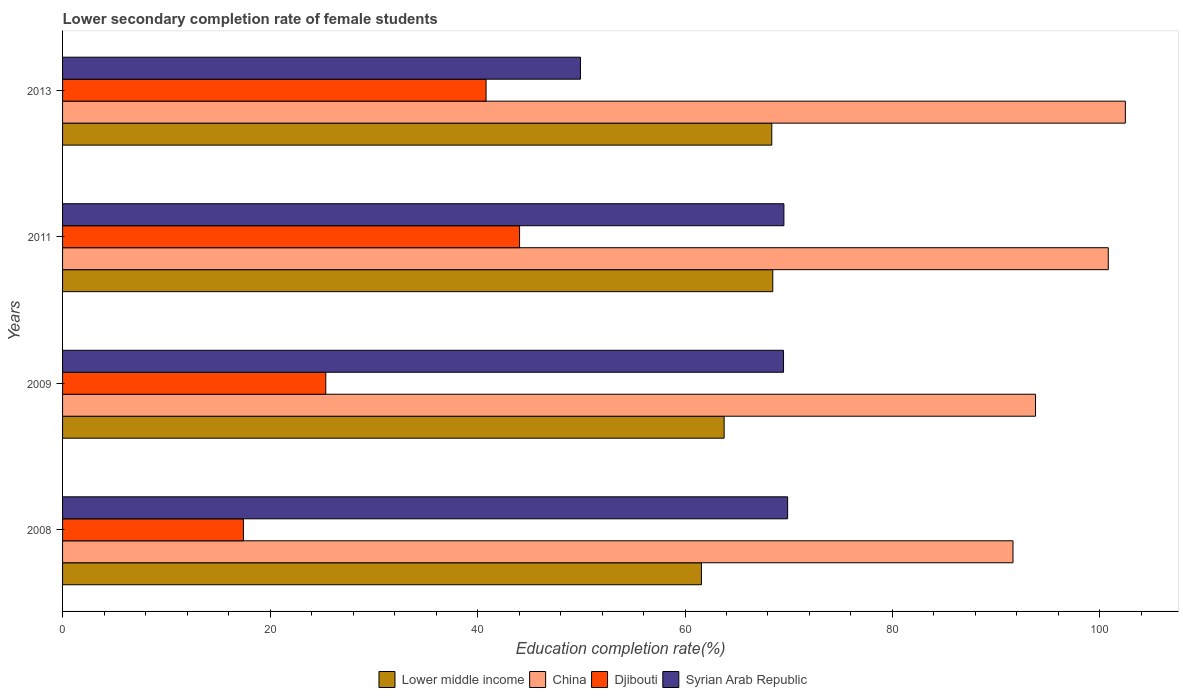Are the number of bars per tick equal to the number of legend labels?
Provide a short and direct response. Yes. How many bars are there on the 3rd tick from the top?
Keep it short and to the point. 4. How many bars are there on the 2nd tick from the bottom?
Your answer should be very brief. 4. In how many cases, is the number of bars for a given year not equal to the number of legend labels?
Offer a terse response. 0. What is the lower secondary completion rate of female students in China in 2011?
Offer a terse response. 100.8. Across all years, what is the maximum lower secondary completion rate of female students in China?
Offer a terse response. 102.45. Across all years, what is the minimum lower secondary completion rate of female students in Djibouti?
Offer a terse response. 17.43. What is the total lower secondary completion rate of female students in China in the graph?
Offer a very short reply. 388.66. What is the difference between the lower secondary completion rate of female students in China in 2008 and that in 2009?
Give a very brief answer. -2.17. What is the difference between the lower secondary completion rate of female students in Syrian Arab Republic in 2011 and the lower secondary completion rate of female students in China in 2008?
Your answer should be very brief. -22.08. What is the average lower secondary completion rate of female students in China per year?
Your response must be concise. 97.17. In the year 2008, what is the difference between the lower secondary completion rate of female students in China and lower secondary completion rate of female students in Djibouti?
Your answer should be compact. 74.18. What is the ratio of the lower secondary completion rate of female students in China in 2008 to that in 2013?
Your answer should be compact. 0.89. Is the lower secondary completion rate of female students in Syrian Arab Republic in 2009 less than that in 2011?
Your answer should be very brief. Yes. Is the difference between the lower secondary completion rate of female students in China in 2011 and 2013 greater than the difference between the lower secondary completion rate of female students in Djibouti in 2011 and 2013?
Offer a terse response. No. What is the difference between the highest and the second highest lower secondary completion rate of female students in Syrian Arab Republic?
Your answer should be very brief. 0.36. What is the difference between the highest and the lowest lower secondary completion rate of female students in Lower middle income?
Offer a very short reply. 6.88. Is the sum of the lower secondary completion rate of female students in Syrian Arab Republic in 2011 and 2013 greater than the maximum lower secondary completion rate of female students in Lower middle income across all years?
Give a very brief answer. Yes. Is it the case that in every year, the sum of the lower secondary completion rate of female students in Lower middle income and lower secondary completion rate of female students in China is greater than the sum of lower secondary completion rate of female students in Syrian Arab Republic and lower secondary completion rate of female students in Djibouti?
Provide a succinct answer. Yes. What does the 4th bar from the top in 2009 represents?
Provide a short and direct response. Lower middle income. What does the 1st bar from the bottom in 2008 represents?
Your response must be concise. Lower middle income. Are all the bars in the graph horizontal?
Offer a very short reply. Yes. Does the graph contain grids?
Your answer should be compact. No. How are the legend labels stacked?
Your response must be concise. Horizontal. What is the title of the graph?
Make the answer very short. Lower secondary completion rate of female students. What is the label or title of the X-axis?
Provide a short and direct response. Education completion rate(%). What is the label or title of the Y-axis?
Make the answer very short. Years. What is the Education completion rate(%) of Lower middle income in 2008?
Give a very brief answer. 61.59. What is the Education completion rate(%) in China in 2008?
Your response must be concise. 91.62. What is the Education completion rate(%) in Djibouti in 2008?
Offer a terse response. 17.43. What is the Education completion rate(%) of Syrian Arab Republic in 2008?
Provide a short and direct response. 69.9. What is the Education completion rate(%) of Lower middle income in 2009?
Offer a terse response. 63.77. What is the Education completion rate(%) of China in 2009?
Keep it short and to the point. 93.79. What is the Education completion rate(%) of Djibouti in 2009?
Ensure brevity in your answer.  25.38. What is the Education completion rate(%) in Syrian Arab Republic in 2009?
Provide a succinct answer. 69.5. What is the Education completion rate(%) in Lower middle income in 2011?
Your answer should be very brief. 68.46. What is the Education completion rate(%) in China in 2011?
Provide a succinct answer. 100.8. What is the Education completion rate(%) in Djibouti in 2011?
Your answer should be very brief. 44.05. What is the Education completion rate(%) of Syrian Arab Republic in 2011?
Make the answer very short. 69.54. What is the Education completion rate(%) in Lower middle income in 2013?
Offer a very short reply. 68.37. What is the Education completion rate(%) of China in 2013?
Provide a short and direct response. 102.45. What is the Education completion rate(%) in Djibouti in 2013?
Provide a short and direct response. 40.82. What is the Education completion rate(%) of Syrian Arab Republic in 2013?
Keep it short and to the point. 49.92. Across all years, what is the maximum Education completion rate(%) in Lower middle income?
Your response must be concise. 68.46. Across all years, what is the maximum Education completion rate(%) in China?
Provide a succinct answer. 102.45. Across all years, what is the maximum Education completion rate(%) of Djibouti?
Make the answer very short. 44.05. Across all years, what is the maximum Education completion rate(%) in Syrian Arab Republic?
Provide a short and direct response. 69.9. Across all years, what is the minimum Education completion rate(%) in Lower middle income?
Your answer should be compact. 61.59. Across all years, what is the minimum Education completion rate(%) of China?
Give a very brief answer. 91.62. Across all years, what is the minimum Education completion rate(%) of Djibouti?
Ensure brevity in your answer.  17.43. Across all years, what is the minimum Education completion rate(%) of Syrian Arab Republic?
Offer a very short reply. 49.92. What is the total Education completion rate(%) of Lower middle income in the graph?
Offer a terse response. 262.19. What is the total Education completion rate(%) of China in the graph?
Your response must be concise. 388.66. What is the total Education completion rate(%) in Djibouti in the graph?
Provide a succinct answer. 127.69. What is the total Education completion rate(%) in Syrian Arab Republic in the graph?
Make the answer very short. 258.85. What is the difference between the Education completion rate(%) of Lower middle income in 2008 and that in 2009?
Your answer should be very brief. -2.19. What is the difference between the Education completion rate(%) in China in 2008 and that in 2009?
Make the answer very short. -2.17. What is the difference between the Education completion rate(%) in Djibouti in 2008 and that in 2009?
Keep it short and to the point. -7.94. What is the difference between the Education completion rate(%) of Syrian Arab Republic in 2008 and that in 2009?
Offer a very short reply. 0.4. What is the difference between the Education completion rate(%) in Lower middle income in 2008 and that in 2011?
Keep it short and to the point. -6.88. What is the difference between the Education completion rate(%) in China in 2008 and that in 2011?
Keep it short and to the point. -9.18. What is the difference between the Education completion rate(%) in Djibouti in 2008 and that in 2011?
Provide a short and direct response. -26.62. What is the difference between the Education completion rate(%) of Syrian Arab Republic in 2008 and that in 2011?
Ensure brevity in your answer.  0.36. What is the difference between the Education completion rate(%) in Lower middle income in 2008 and that in 2013?
Provide a succinct answer. -6.78. What is the difference between the Education completion rate(%) of China in 2008 and that in 2013?
Your response must be concise. -10.83. What is the difference between the Education completion rate(%) of Djibouti in 2008 and that in 2013?
Your response must be concise. -23.39. What is the difference between the Education completion rate(%) of Syrian Arab Republic in 2008 and that in 2013?
Offer a terse response. 19.97. What is the difference between the Education completion rate(%) in Lower middle income in 2009 and that in 2011?
Provide a short and direct response. -4.69. What is the difference between the Education completion rate(%) in China in 2009 and that in 2011?
Offer a terse response. -7.01. What is the difference between the Education completion rate(%) in Djibouti in 2009 and that in 2011?
Offer a very short reply. -18.68. What is the difference between the Education completion rate(%) in Syrian Arab Republic in 2009 and that in 2011?
Provide a short and direct response. -0.04. What is the difference between the Education completion rate(%) in Lower middle income in 2009 and that in 2013?
Offer a terse response. -4.59. What is the difference between the Education completion rate(%) in China in 2009 and that in 2013?
Offer a terse response. -8.66. What is the difference between the Education completion rate(%) of Djibouti in 2009 and that in 2013?
Make the answer very short. -15.45. What is the difference between the Education completion rate(%) in Syrian Arab Republic in 2009 and that in 2013?
Ensure brevity in your answer.  19.58. What is the difference between the Education completion rate(%) in Lower middle income in 2011 and that in 2013?
Make the answer very short. 0.09. What is the difference between the Education completion rate(%) in China in 2011 and that in 2013?
Give a very brief answer. -1.65. What is the difference between the Education completion rate(%) of Djibouti in 2011 and that in 2013?
Keep it short and to the point. 3.23. What is the difference between the Education completion rate(%) in Syrian Arab Republic in 2011 and that in 2013?
Ensure brevity in your answer.  19.61. What is the difference between the Education completion rate(%) in Lower middle income in 2008 and the Education completion rate(%) in China in 2009?
Keep it short and to the point. -32.2. What is the difference between the Education completion rate(%) of Lower middle income in 2008 and the Education completion rate(%) of Djibouti in 2009?
Your response must be concise. 36.21. What is the difference between the Education completion rate(%) of Lower middle income in 2008 and the Education completion rate(%) of Syrian Arab Republic in 2009?
Keep it short and to the point. -7.91. What is the difference between the Education completion rate(%) of China in 2008 and the Education completion rate(%) of Djibouti in 2009?
Offer a very short reply. 66.24. What is the difference between the Education completion rate(%) in China in 2008 and the Education completion rate(%) in Syrian Arab Republic in 2009?
Offer a terse response. 22.12. What is the difference between the Education completion rate(%) of Djibouti in 2008 and the Education completion rate(%) of Syrian Arab Republic in 2009?
Give a very brief answer. -52.06. What is the difference between the Education completion rate(%) of Lower middle income in 2008 and the Education completion rate(%) of China in 2011?
Offer a terse response. -39.22. What is the difference between the Education completion rate(%) of Lower middle income in 2008 and the Education completion rate(%) of Djibouti in 2011?
Your response must be concise. 17.53. What is the difference between the Education completion rate(%) in Lower middle income in 2008 and the Education completion rate(%) in Syrian Arab Republic in 2011?
Provide a short and direct response. -7.95. What is the difference between the Education completion rate(%) of China in 2008 and the Education completion rate(%) of Djibouti in 2011?
Make the answer very short. 47.56. What is the difference between the Education completion rate(%) of China in 2008 and the Education completion rate(%) of Syrian Arab Republic in 2011?
Offer a very short reply. 22.08. What is the difference between the Education completion rate(%) in Djibouti in 2008 and the Education completion rate(%) in Syrian Arab Republic in 2011?
Offer a very short reply. -52.1. What is the difference between the Education completion rate(%) in Lower middle income in 2008 and the Education completion rate(%) in China in 2013?
Your response must be concise. -40.86. What is the difference between the Education completion rate(%) in Lower middle income in 2008 and the Education completion rate(%) in Djibouti in 2013?
Make the answer very short. 20.76. What is the difference between the Education completion rate(%) of Lower middle income in 2008 and the Education completion rate(%) of Syrian Arab Republic in 2013?
Provide a succinct answer. 11.66. What is the difference between the Education completion rate(%) of China in 2008 and the Education completion rate(%) of Djibouti in 2013?
Your response must be concise. 50.79. What is the difference between the Education completion rate(%) of China in 2008 and the Education completion rate(%) of Syrian Arab Republic in 2013?
Keep it short and to the point. 41.7. What is the difference between the Education completion rate(%) in Djibouti in 2008 and the Education completion rate(%) in Syrian Arab Republic in 2013?
Your answer should be very brief. -32.49. What is the difference between the Education completion rate(%) in Lower middle income in 2009 and the Education completion rate(%) in China in 2011?
Give a very brief answer. -37.03. What is the difference between the Education completion rate(%) in Lower middle income in 2009 and the Education completion rate(%) in Djibouti in 2011?
Provide a succinct answer. 19.72. What is the difference between the Education completion rate(%) of Lower middle income in 2009 and the Education completion rate(%) of Syrian Arab Republic in 2011?
Offer a very short reply. -5.76. What is the difference between the Education completion rate(%) of China in 2009 and the Education completion rate(%) of Djibouti in 2011?
Ensure brevity in your answer.  49.74. What is the difference between the Education completion rate(%) in China in 2009 and the Education completion rate(%) in Syrian Arab Republic in 2011?
Your answer should be very brief. 24.26. What is the difference between the Education completion rate(%) of Djibouti in 2009 and the Education completion rate(%) of Syrian Arab Republic in 2011?
Offer a very short reply. -44.16. What is the difference between the Education completion rate(%) in Lower middle income in 2009 and the Education completion rate(%) in China in 2013?
Keep it short and to the point. -38.68. What is the difference between the Education completion rate(%) in Lower middle income in 2009 and the Education completion rate(%) in Djibouti in 2013?
Provide a succinct answer. 22.95. What is the difference between the Education completion rate(%) in Lower middle income in 2009 and the Education completion rate(%) in Syrian Arab Republic in 2013?
Your answer should be very brief. 13.85. What is the difference between the Education completion rate(%) of China in 2009 and the Education completion rate(%) of Djibouti in 2013?
Your answer should be compact. 52.97. What is the difference between the Education completion rate(%) of China in 2009 and the Education completion rate(%) of Syrian Arab Republic in 2013?
Offer a very short reply. 43.87. What is the difference between the Education completion rate(%) in Djibouti in 2009 and the Education completion rate(%) in Syrian Arab Republic in 2013?
Your answer should be very brief. -24.55. What is the difference between the Education completion rate(%) of Lower middle income in 2011 and the Education completion rate(%) of China in 2013?
Offer a very short reply. -33.99. What is the difference between the Education completion rate(%) of Lower middle income in 2011 and the Education completion rate(%) of Djibouti in 2013?
Ensure brevity in your answer.  27.64. What is the difference between the Education completion rate(%) in Lower middle income in 2011 and the Education completion rate(%) in Syrian Arab Republic in 2013?
Your response must be concise. 18.54. What is the difference between the Education completion rate(%) in China in 2011 and the Education completion rate(%) in Djibouti in 2013?
Offer a terse response. 59.98. What is the difference between the Education completion rate(%) of China in 2011 and the Education completion rate(%) of Syrian Arab Republic in 2013?
Provide a short and direct response. 50.88. What is the difference between the Education completion rate(%) of Djibouti in 2011 and the Education completion rate(%) of Syrian Arab Republic in 2013?
Offer a terse response. -5.87. What is the average Education completion rate(%) in Lower middle income per year?
Make the answer very short. 65.55. What is the average Education completion rate(%) in China per year?
Provide a succinct answer. 97.17. What is the average Education completion rate(%) in Djibouti per year?
Keep it short and to the point. 31.92. What is the average Education completion rate(%) in Syrian Arab Republic per year?
Make the answer very short. 64.71. In the year 2008, what is the difference between the Education completion rate(%) in Lower middle income and Education completion rate(%) in China?
Offer a terse response. -30.03. In the year 2008, what is the difference between the Education completion rate(%) in Lower middle income and Education completion rate(%) in Djibouti?
Keep it short and to the point. 44.15. In the year 2008, what is the difference between the Education completion rate(%) in Lower middle income and Education completion rate(%) in Syrian Arab Republic?
Keep it short and to the point. -8.31. In the year 2008, what is the difference between the Education completion rate(%) in China and Education completion rate(%) in Djibouti?
Provide a short and direct response. 74.18. In the year 2008, what is the difference between the Education completion rate(%) in China and Education completion rate(%) in Syrian Arab Republic?
Make the answer very short. 21.72. In the year 2008, what is the difference between the Education completion rate(%) of Djibouti and Education completion rate(%) of Syrian Arab Republic?
Provide a short and direct response. -52.46. In the year 2009, what is the difference between the Education completion rate(%) of Lower middle income and Education completion rate(%) of China?
Your answer should be very brief. -30.02. In the year 2009, what is the difference between the Education completion rate(%) in Lower middle income and Education completion rate(%) in Djibouti?
Offer a very short reply. 38.4. In the year 2009, what is the difference between the Education completion rate(%) of Lower middle income and Education completion rate(%) of Syrian Arab Republic?
Offer a very short reply. -5.72. In the year 2009, what is the difference between the Education completion rate(%) in China and Education completion rate(%) in Djibouti?
Your response must be concise. 68.42. In the year 2009, what is the difference between the Education completion rate(%) in China and Education completion rate(%) in Syrian Arab Republic?
Ensure brevity in your answer.  24.29. In the year 2009, what is the difference between the Education completion rate(%) in Djibouti and Education completion rate(%) in Syrian Arab Republic?
Your response must be concise. -44.12. In the year 2011, what is the difference between the Education completion rate(%) of Lower middle income and Education completion rate(%) of China?
Your answer should be very brief. -32.34. In the year 2011, what is the difference between the Education completion rate(%) in Lower middle income and Education completion rate(%) in Djibouti?
Keep it short and to the point. 24.41. In the year 2011, what is the difference between the Education completion rate(%) of Lower middle income and Education completion rate(%) of Syrian Arab Republic?
Your response must be concise. -1.07. In the year 2011, what is the difference between the Education completion rate(%) of China and Education completion rate(%) of Djibouti?
Your answer should be compact. 56.75. In the year 2011, what is the difference between the Education completion rate(%) of China and Education completion rate(%) of Syrian Arab Republic?
Your answer should be compact. 31.27. In the year 2011, what is the difference between the Education completion rate(%) of Djibouti and Education completion rate(%) of Syrian Arab Republic?
Keep it short and to the point. -25.48. In the year 2013, what is the difference between the Education completion rate(%) in Lower middle income and Education completion rate(%) in China?
Give a very brief answer. -34.08. In the year 2013, what is the difference between the Education completion rate(%) in Lower middle income and Education completion rate(%) in Djibouti?
Make the answer very short. 27.54. In the year 2013, what is the difference between the Education completion rate(%) in Lower middle income and Education completion rate(%) in Syrian Arab Republic?
Provide a succinct answer. 18.45. In the year 2013, what is the difference between the Education completion rate(%) in China and Education completion rate(%) in Djibouti?
Make the answer very short. 61.62. In the year 2013, what is the difference between the Education completion rate(%) of China and Education completion rate(%) of Syrian Arab Republic?
Ensure brevity in your answer.  52.53. In the year 2013, what is the difference between the Education completion rate(%) in Djibouti and Education completion rate(%) in Syrian Arab Republic?
Offer a terse response. -9.1. What is the ratio of the Education completion rate(%) of Lower middle income in 2008 to that in 2009?
Provide a short and direct response. 0.97. What is the ratio of the Education completion rate(%) of China in 2008 to that in 2009?
Your answer should be compact. 0.98. What is the ratio of the Education completion rate(%) of Djibouti in 2008 to that in 2009?
Provide a succinct answer. 0.69. What is the ratio of the Education completion rate(%) in Lower middle income in 2008 to that in 2011?
Provide a short and direct response. 0.9. What is the ratio of the Education completion rate(%) of China in 2008 to that in 2011?
Your answer should be compact. 0.91. What is the ratio of the Education completion rate(%) of Djibouti in 2008 to that in 2011?
Your response must be concise. 0.4. What is the ratio of the Education completion rate(%) in Lower middle income in 2008 to that in 2013?
Your answer should be very brief. 0.9. What is the ratio of the Education completion rate(%) of China in 2008 to that in 2013?
Your answer should be very brief. 0.89. What is the ratio of the Education completion rate(%) of Djibouti in 2008 to that in 2013?
Give a very brief answer. 0.43. What is the ratio of the Education completion rate(%) of Syrian Arab Republic in 2008 to that in 2013?
Your answer should be very brief. 1.4. What is the ratio of the Education completion rate(%) of Lower middle income in 2009 to that in 2011?
Ensure brevity in your answer.  0.93. What is the ratio of the Education completion rate(%) of China in 2009 to that in 2011?
Make the answer very short. 0.93. What is the ratio of the Education completion rate(%) in Djibouti in 2009 to that in 2011?
Provide a succinct answer. 0.58. What is the ratio of the Education completion rate(%) in Lower middle income in 2009 to that in 2013?
Provide a short and direct response. 0.93. What is the ratio of the Education completion rate(%) in China in 2009 to that in 2013?
Your answer should be compact. 0.92. What is the ratio of the Education completion rate(%) of Djibouti in 2009 to that in 2013?
Your answer should be compact. 0.62. What is the ratio of the Education completion rate(%) of Syrian Arab Republic in 2009 to that in 2013?
Give a very brief answer. 1.39. What is the ratio of the Education completion rate(%) of China in 2011 to that in 2013?
Offer a terse response. 0.98. What is the ratio of the Education completion rate(%) of Djibouti in 2011 to that in 2013?
Offer a very short reply. 1.08. What is the ratio of the Education completion rate(%) in Syrian Arab Republic in 2011 to that in 2013?
Your answer should be compact. 1.39. What is the difference between the highest and the second highest Education completion rate(%) of Lower middle income?
Give a very brief answer. 0.09. What is the difference between the highest and the second highest Education completion rate(%) in China?
Offer a very short reply. 1.65. What is the difference between the highest and the second highest Education completion rate(%) in Djibouti?
Keep it short and to the point. 3.23. What is the difference between the highest and the second highest Education completion rate(%) of Syrian Arab Republic?
Offer a very short reply. 0.36. What is the difference between the highest and the lowest Education completion rate(%) of Lower middle income?
Your response must be concise. 6.88. What is the difference between the highest and the lowest Education completion rate(%) of China?
Provide a short and direct response. 10.83. What is the difference between the highest and the lowest Education completion rate(%) in Djibouti?
Make the answer very short. 26.62. What is the difference between the highest and the lowest Education completion rate(%) of Syrian Arab Republic?
Your response must be concise. 19.97. 